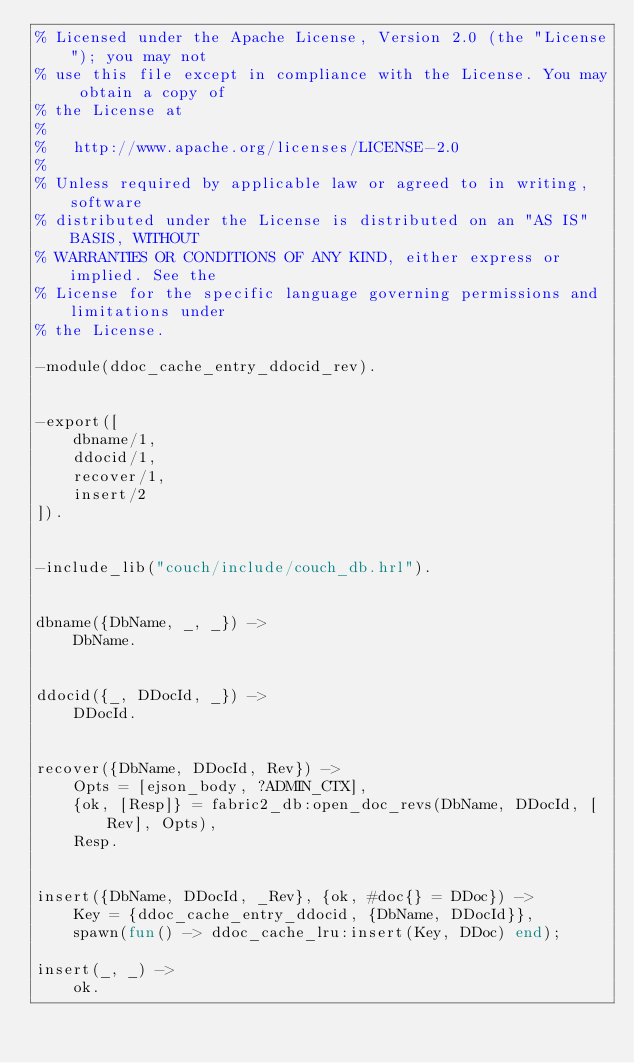<code> <loc_0><loc_0><loc_500><loc_500><_Erlang_>% Licensed under the Apache License, Version 2.0 (the "License"); you may not
% use this file except in compliance with the License. You may obtain a copy of
% the License at
%
%   http://www.apache.org/licenses/LICENSE-2.0
%
% Unless required by applicable law or agreed to in writing, software
% distributed under the License is distributed on an "AS IS" BASIS, WITHOUT
% WARRANTIES OR CONDITIONS OF ANY KIND, either express or implied. See the
% License for the specific language governing permissions and limitations under
% the License.

-module(ddoc_cache_entry_ddocid_rev).


-export([
    dbname/1,
    ddocid/1,
    recover/1,
    insert/2
]).


-include_lib("couch/include/couch_db.hrl").


dbname({DbName, _, _}) ->
    DbName.


ddocid({_, DDocId, _}) ->
    DDocId.


recover({DbName, DDocId, Rev}) ->
    Opts = [ejson_body, ?ADMIN_CTX],
    {ok, [Resp]} = fabric2_db:open_doc_revs(DbName, DDocId, [Rev], Opts),
    Resp.


insert({DbName, DDocId, _Rev}, {ok, #doc{} = DDoc}) ->
    Key = {ddoc_cache_entry_ddocid, {DbName, DDocId}},
    spawn(fun() -> ddoc_cache_lru:insert(Key, DDoc) end);

insert(_, _) ->
    ok.

</code> 